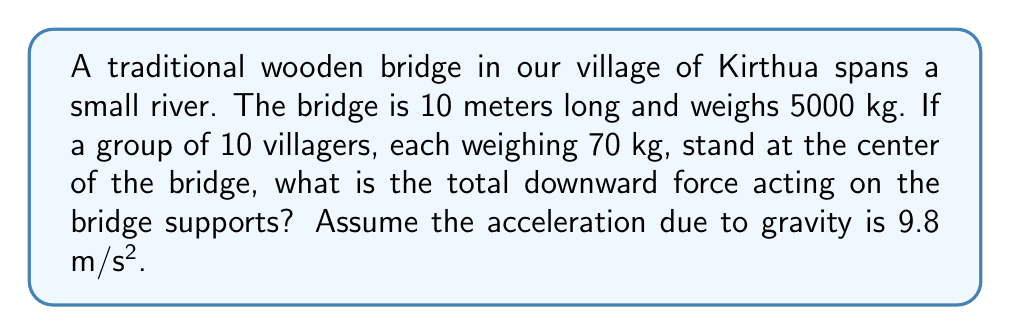Help me with this question. Let's approach this problem step-by-step:

1) First, we need to calculate the weight of the bridge:
   $$F_{bridge} = m_{bridge} \times g$$
   where $m_{bridge}$ is the mass of the bridge and $g$ is the acceleration due to gravity.
   $$F_{bridge} = 5000 \text{ kg} \times 9.8 \text{ m/s²} = 49000 \text{ N}$$

2) Next, we calculate the total weight of the villagers:
   $$F_{villagers} = n \times m_{villager} \times g$$
   where $n$ is the number of villagers and $m_{villager}$ is the mass of each villager.
   $$F_{villagers} = 10 \times 70 \text{ kg} \times 9.8 \text{ m/s²} = 6860 \text{ N}$$

3) The total downward force is the sum of these two forces:
   $$F_{total} = F_{bridge} + F_{villagers}$$
   $$F_{total} = 49000 \text{ N} + 6860 \text{ N} = 55860 \text{ N}$$

This total force is distributed between the two supports of the bridge. In a simple model, we can assume each support bears half of the total load:

$$F_{support} = \frac{F_{total}}{2} = \frac{55860 \text{ N}}{2} = 27930 \text{ N}$$

However, the question asks for the total downward force on the bridge supports, which is the full 55860 N.
Answer: 55860 N 